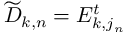<formula> <loc_0><loc_0><loc_500><loc_500>\widetilde { D } _ { k , n } = E _ { k , j _ { n } } ^ { t }</formula> 